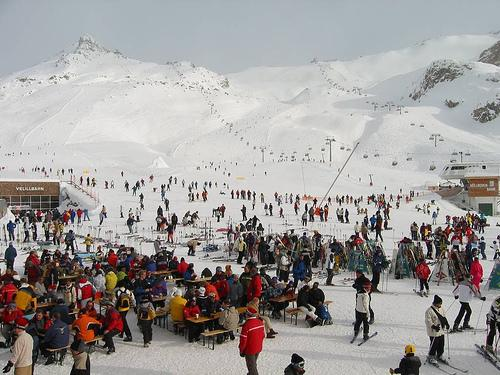What is on the floor?

Choices:
A) milk
B) bananas
C) sand
D) crumbs sand 